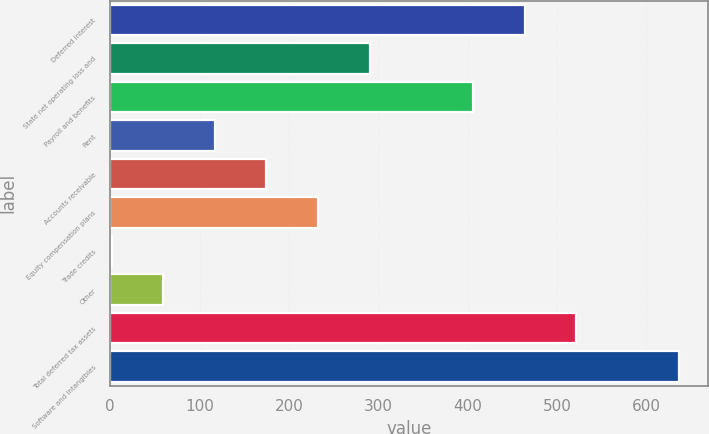Convert chart. <chart><loc_0><loc_0><loc_500><loc_500><bar_chart><fcel>Deferred interest<fcel>State net operating loss and<fcel>Payroll and benefits<fcel>Rent<fcel>Accounts receivable<fcel>Equity compensation plans<fcel>Trade credits<fcel>Other<fcel>Total deferred tax assets<fcel>Software and intangibles<nl><fcel>463.74<fcel>290.4<fcel>405.96<fcel>117.06<fcel>174.84<fcel>232.62<fcel>1.5<fcel>59.28<fcel>521.52<fcel>637.08<nl></chart> 